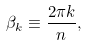<formula> <loc_0><loc_0><loc_500><loc_500>\beta _ { k } \equiv \frac { 2 \pi k } { n } ,</formula> 